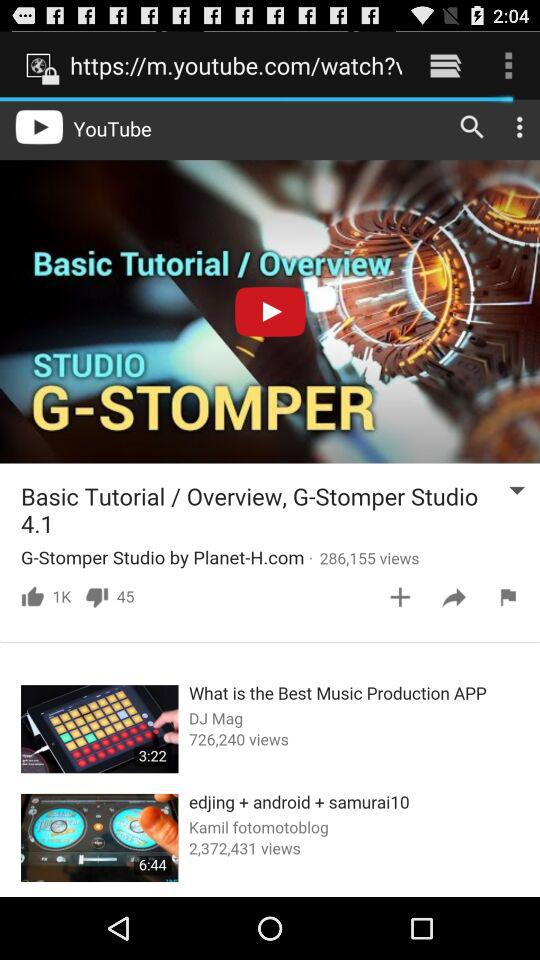What is the version of G-Stomper Studio? The version is 4.1. 